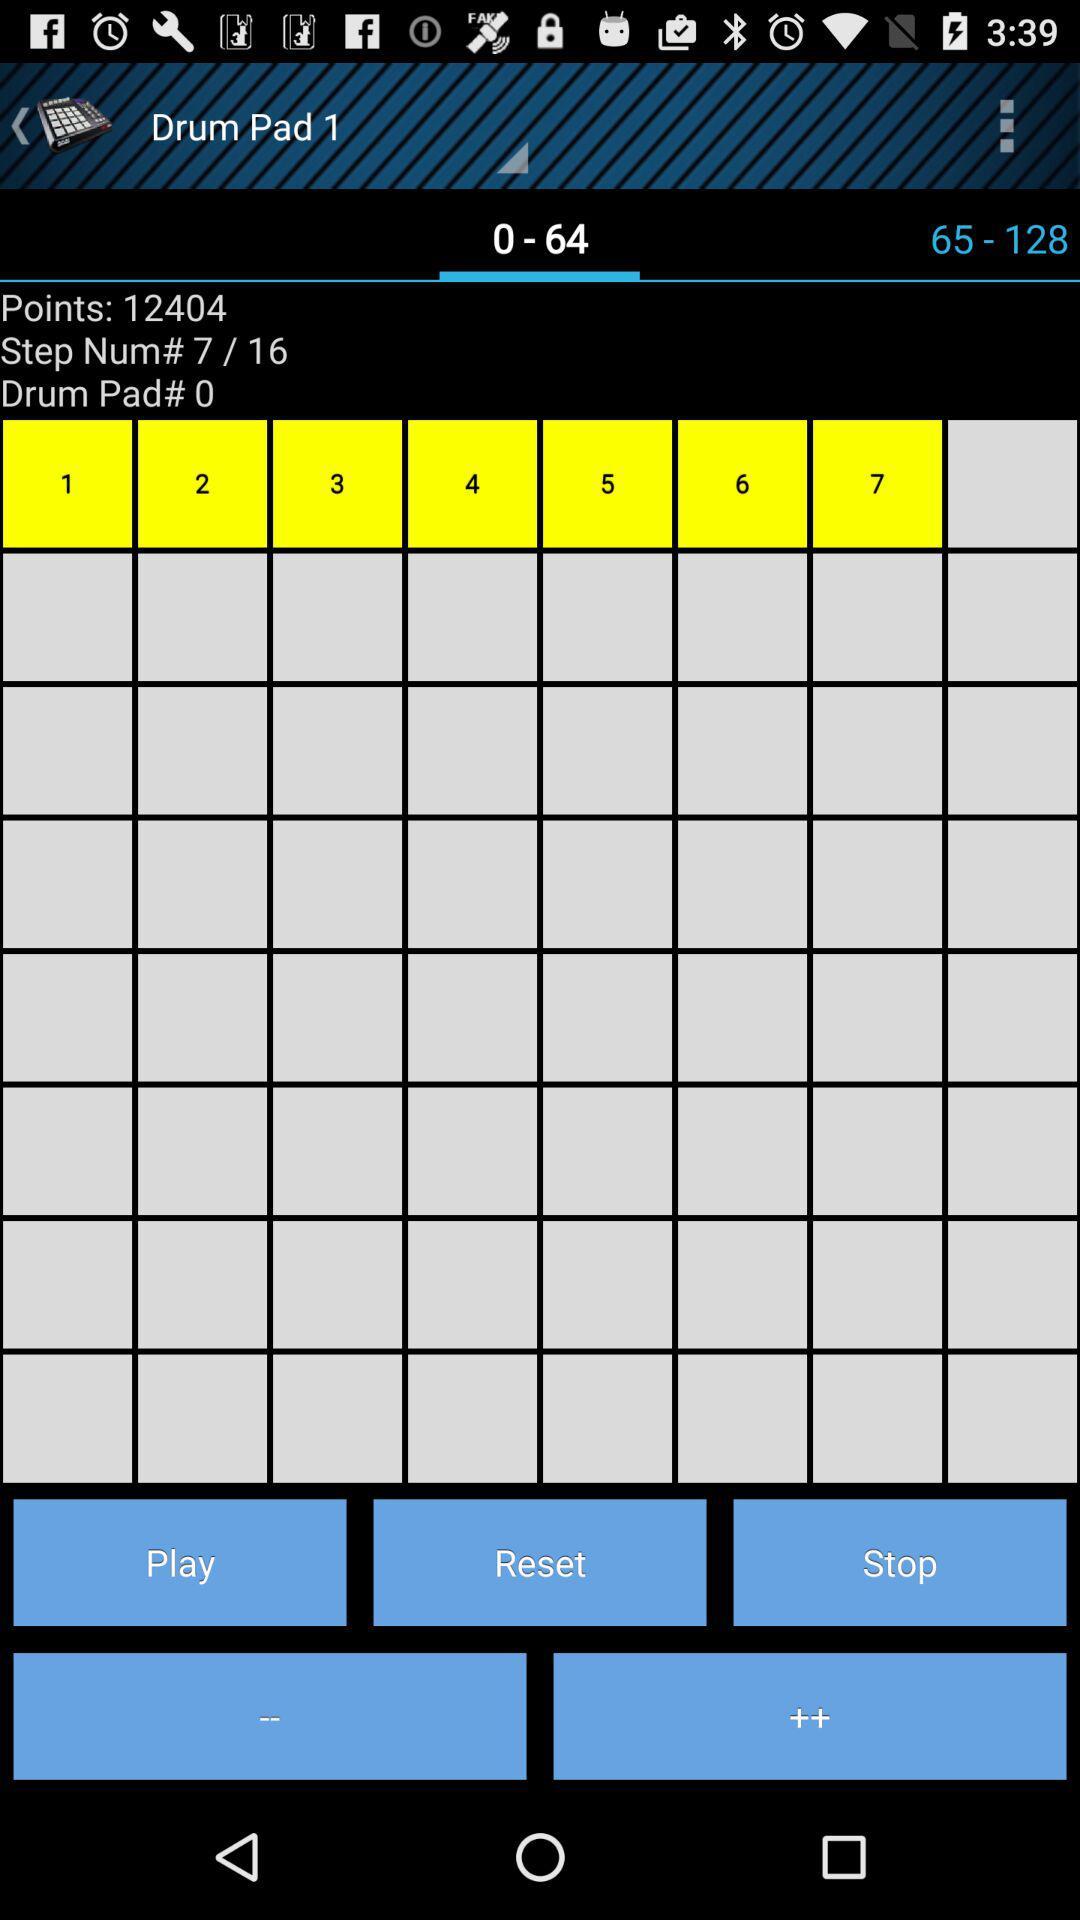How many points are there? There are 12404 points. 